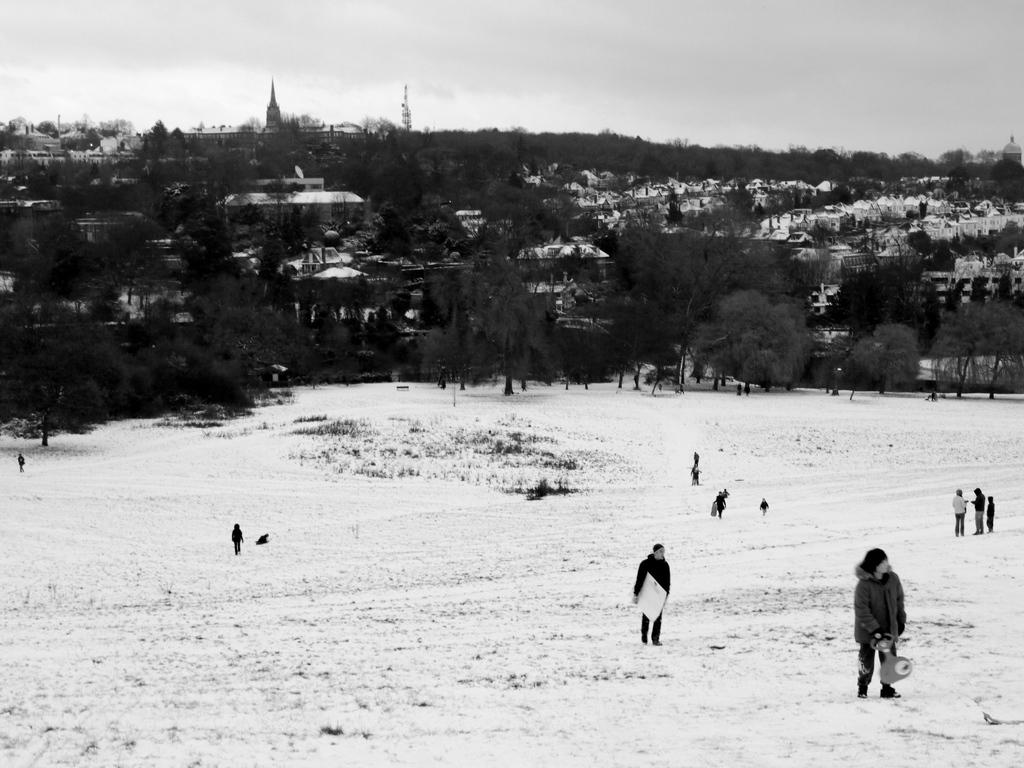What is the surface that the people are standing on in the image? The people are standing on the surface of the snow in the image. What are the people holding in their hands? The people are holding objects in their hands in the image. What can be seen in the background of the image? There are trees, buildings, and the sky visible in the background of the image. Where is the stove located in the image? There is no stove present in the image. What type of addition is being made to the buildings in the image? There is no addition being made to the buildings in the image; they are already complete structures. 